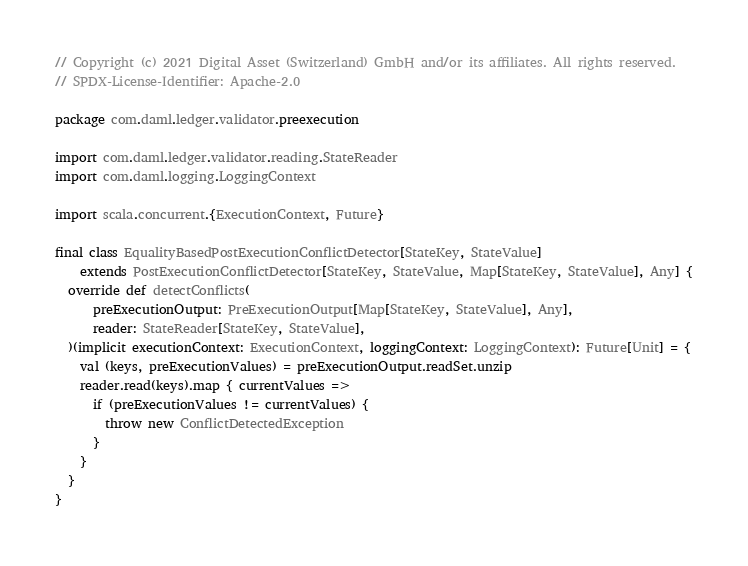<code> <loc_0><loc_0><loc_500><loc_500><_Scala_>// Copyright (c) 2021 Digital Asset (Switzerland) GmbH and/or its affiliates. All rights reserved.
// SPDX-License-Identifier: Apache-2.0

package com.daml.ledger.validator.preexecution

import com.daml.ledger.validator.reading.StateReader
import com.daml.logging.LoggingContext

import scala.concurrent.{ExecutionContext, Future}

final class EqualityBasedPostExecutionConflictDetector[StateKey, StateValue]
    extends PostExecutionConflictDetector[StateKey, StateValue, Map[StateKey, StateValue], Any] {
  override def detectConflicts(
      preExecutionOutput: PreExecutionOutput[Map[StateKey, StateValue], Any],
      reader: StateReader[StateKey, StateValue],
  )(implicit executionContext: ExecutionContext, loggingContext: LoggingContext): Future[Unit] = {
    val (keys, preExecutionValues) = preExecutionOutput.readSet.unzip
    reader.read(keys).map { currentValues =>
      if (preExecutionValues != currentValues) {
        throw new ConflictDetectedException
      }
    }
  }
}
</code> 